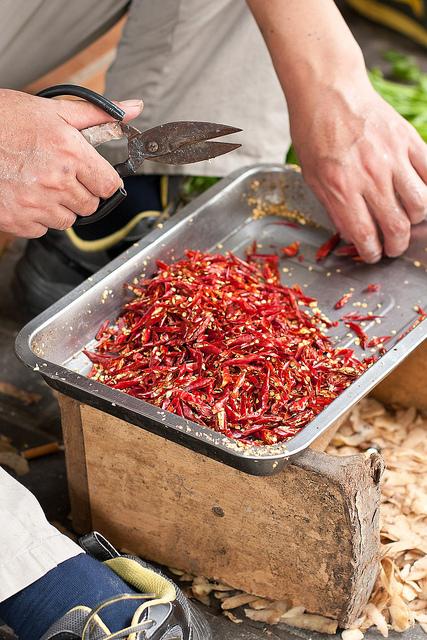Is that food the man is cutting up?
Concise answer only. Yes. Does this person have a thumb on his left hand?
Be succinct. Yes. Is this person sitting in a chair?
Answer briefly. No. 